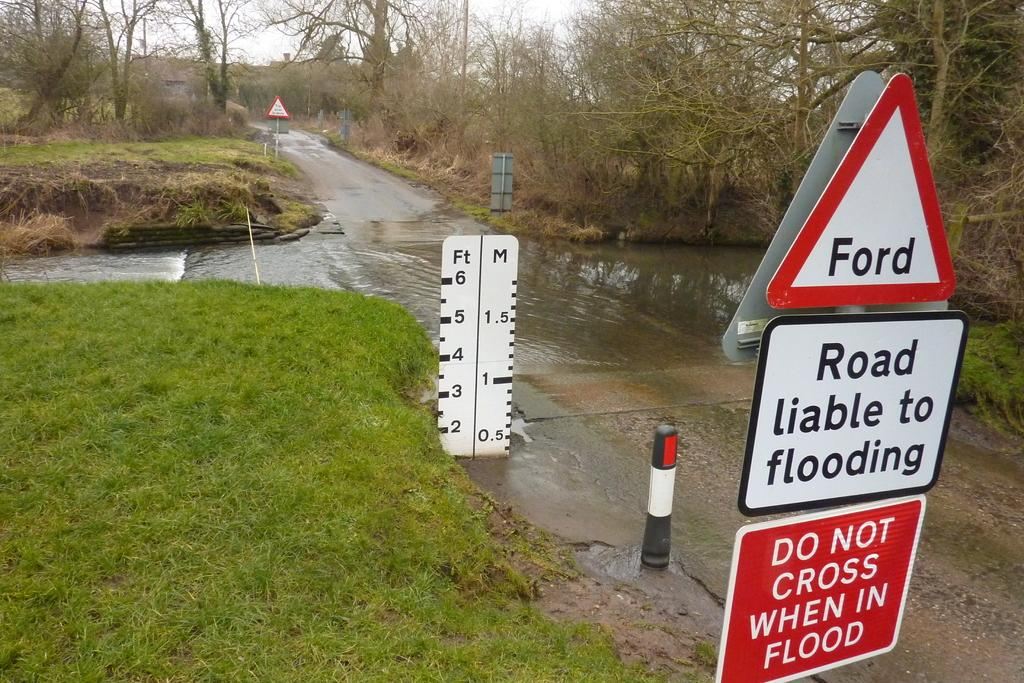Provide a one-sentence caption for the provided image. Road sign reading Road liable to flooding in front of an intersection that is flooded with water. 